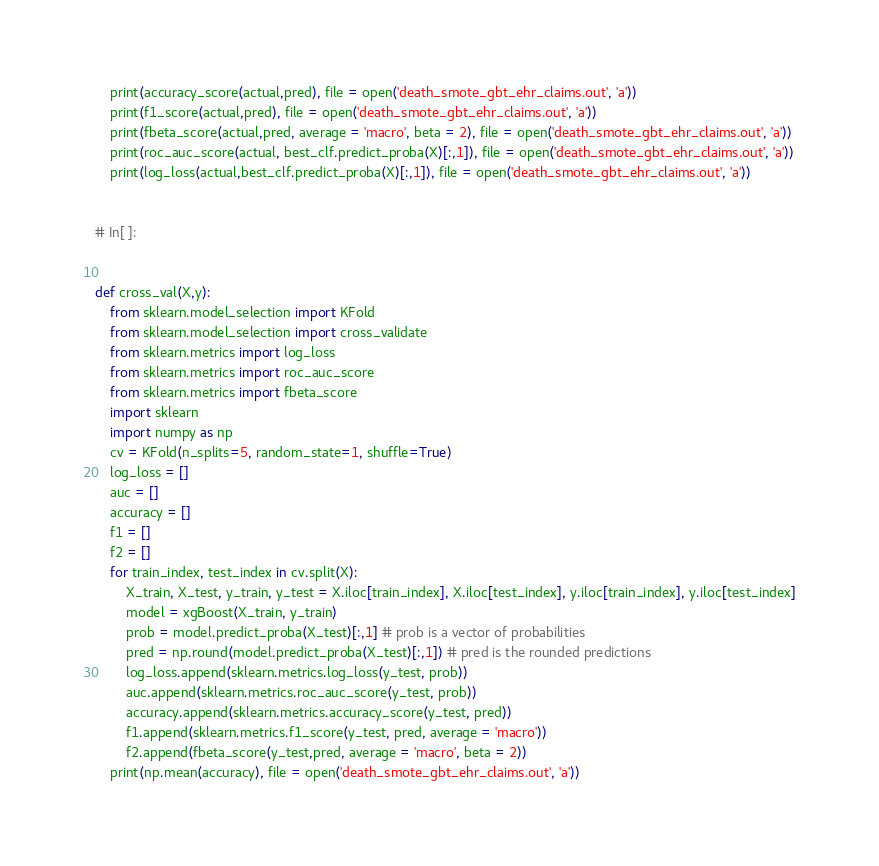Convert code to text. <code><loc_0><loc_0><loc_500><loc_500><_Python_>    print(accuracy_score(actual,pred), file = open('death_smote_gbt_ehr_claims.out', 'a'))
    print(f1_score(actual,pred), file = open('death_smote_gbt_ehr_claims.out', 'a'))
    print(fbeta_score(actual,pred, average = 'macro', beta = 2), file = open('death_smote_gbt_ehr_claims.out', 'a'))
    print(roc_auc_score(actual, best_clf.predict_proba(X)[:,1]), file = open('death_smote_gbt_ehr_claims.out', 'a'))
    print(log_loss(actual,best_clf.predict_proba(X)[:,1]), file = open('death_smote_gbt_ehr_claims.out', 'a'))


# In[ ]:


def cross_val(X,y):
    from sklearn.model_selection import KFold
    from sklearn.model_selection import cross_validate
    from sklearn.metrics import log_loss
    from sklearn.metrics import roc_auc_score
    from sklearn.metrics import fbeta_score
    import sklearn
    import numpy as np
    cv = KFold(n_splits=5, random_state=1, shuffle=True)
    log_loss = [] 
    auc = [] 
    accuracy = []
    f1 = []
    f2 = [] 
    for train_index, test_index in cv.split(X):
        X_train, X_test, y_train, y_test = X.iloc[train_index], X.iloc[test_index], y.iloc[train_index], y.iloc[test_index]
        model = xgBoost(X_train, y_train)
        prob = model.predict_proba(X_test)[:,1] # prob is a vector of probabilities 
        pred = np.round(model.predict_proba(X_test)[:,1]) # pred is the rounded predictions 
        log_loss.append(sklearn.metrics.log_loss(y_test, prob))
        auc.append(sklearn.metrics.roc_auc_score(y_test, prob))
        accuracy.append(sklearn.metrics.accuracy_score(y_test, pred))
        f1.append(sklearn.metrics.f1_score(y_test, pred, average = 'macro'))
        f2.append(fbeta_score(y_test,pred, average = 'macro', beta = 2))
    print(np.mean(accuracy), file = open('death_smote_gbt_ehr_claims.out', 'a'))</code> 